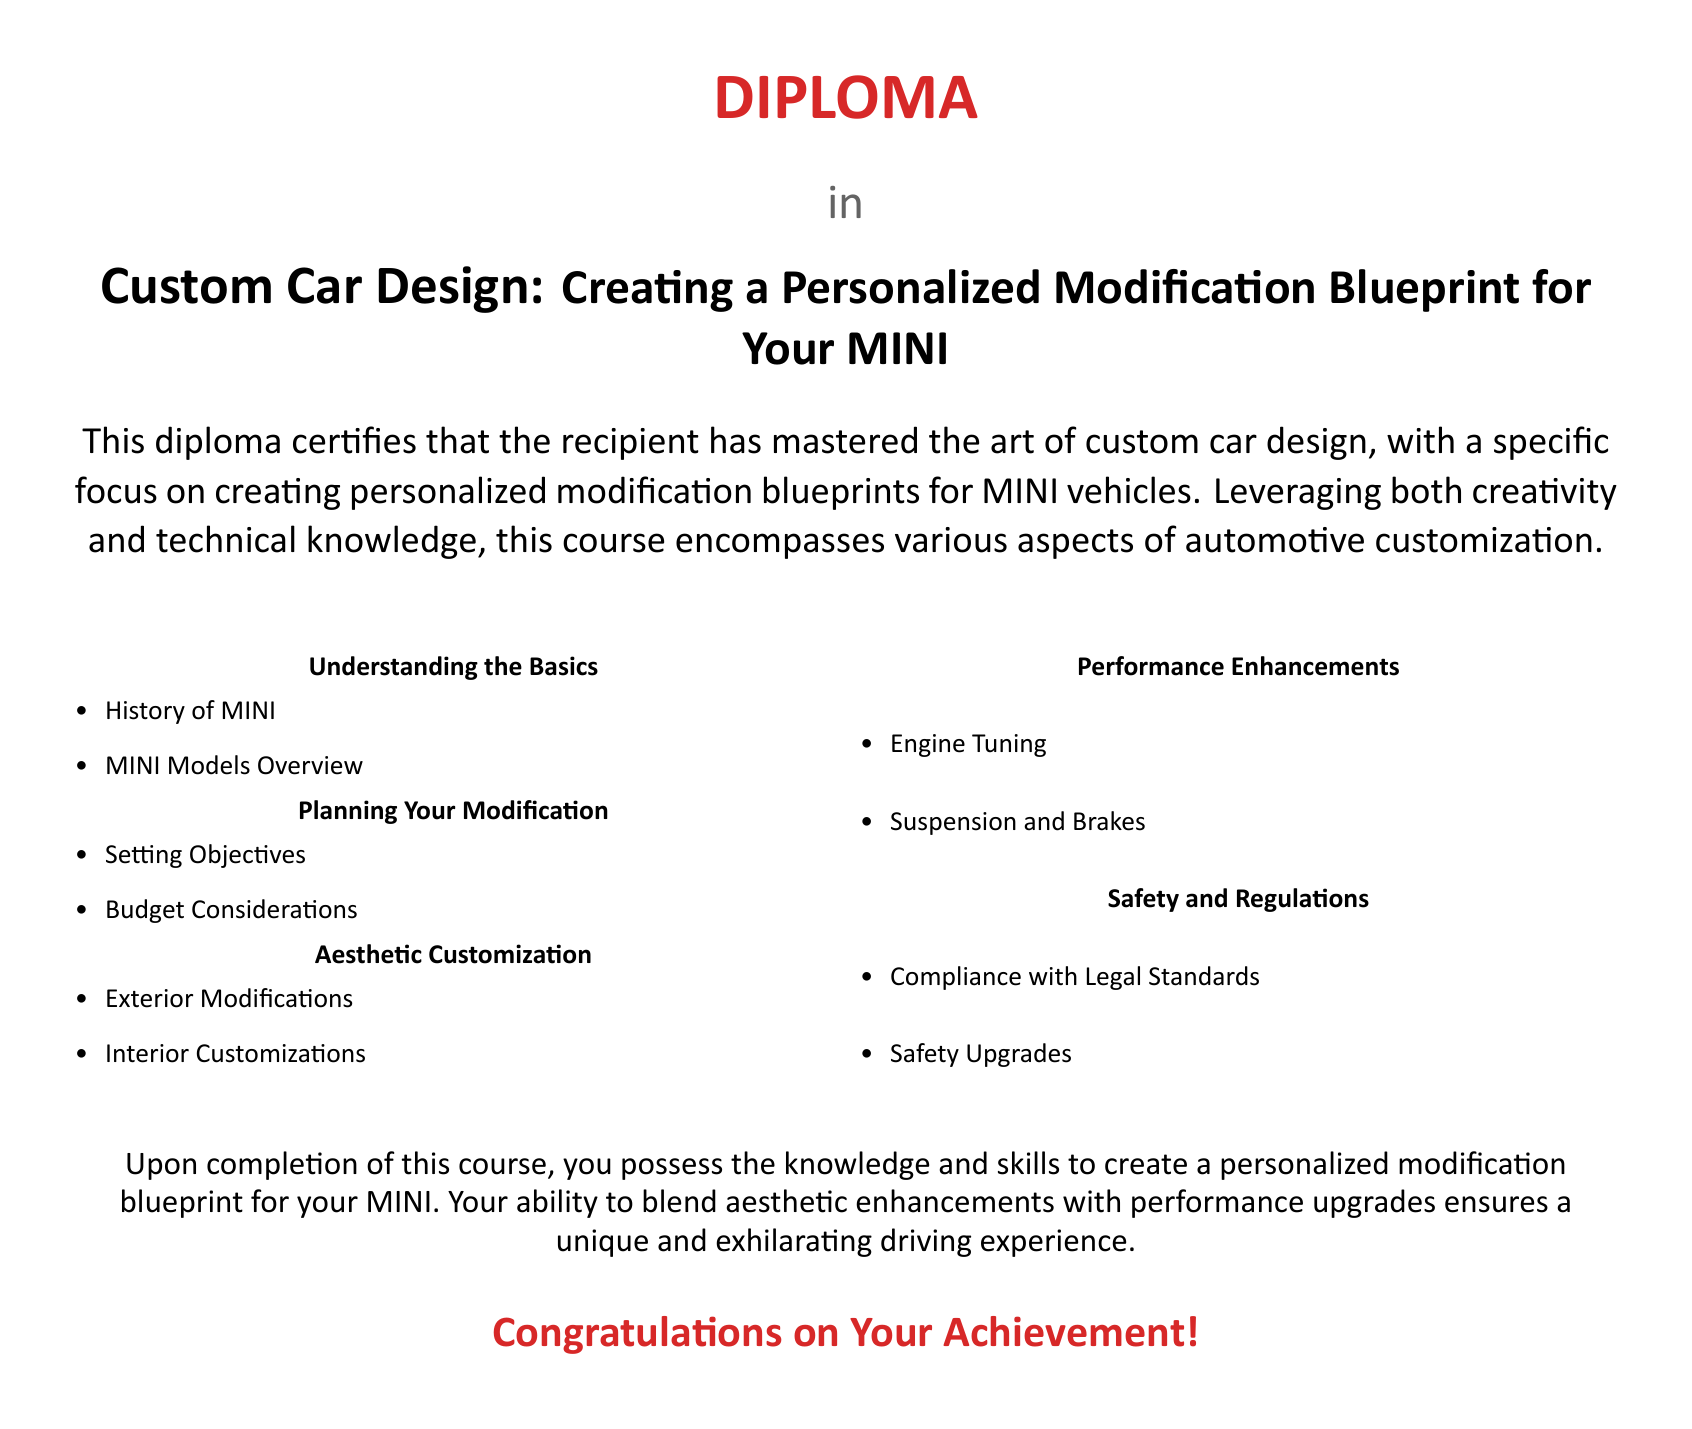What is the title of the diploma? The title of the diploma is located at the top of the document, indicating the focus on custom car design for MINI vehicles.
Answer: Custom Car Design: Creating a Personalized Modification Blueprint for Your MINI What color is used for the diploma title? The document specifies the color used for the title, which is clearly noted as a specific RGB value.
Answer: minired What are the two main areas covered in the document? The document outlines several key areas of focus; however, two prominent themes are mentioned clearly under their respective headings.
Answer: Aesthetic Customization, Performance Enhancements What is the significance of the diploma? The document states the achievement of the recipient in mastering specific skills and knowledge related to custom car design, which conveys the value of the diploma.
Answer: Mastered the art of custom car design How many columns are used in the document? The layout of the document is organized into a specific number of columns for presenting information clearly.
Answer: 2 What is one of the planning aspects mentioned? The planning section of the document identifies various factors that need to be considered when planning modifications.
Answer: Budget Considerations What type of upgrades does the document mention under safety? The document categorically addresses enhancements related to safety, highlighting a specific aspect of car modification.
Answer: Safety Upgrades What is the final congratulatory message in the document? The conclusion of the document contains a celebratory statement directed towards the recipient, indicating successful completion.
Answer: Congratulations on Your Achievement! 